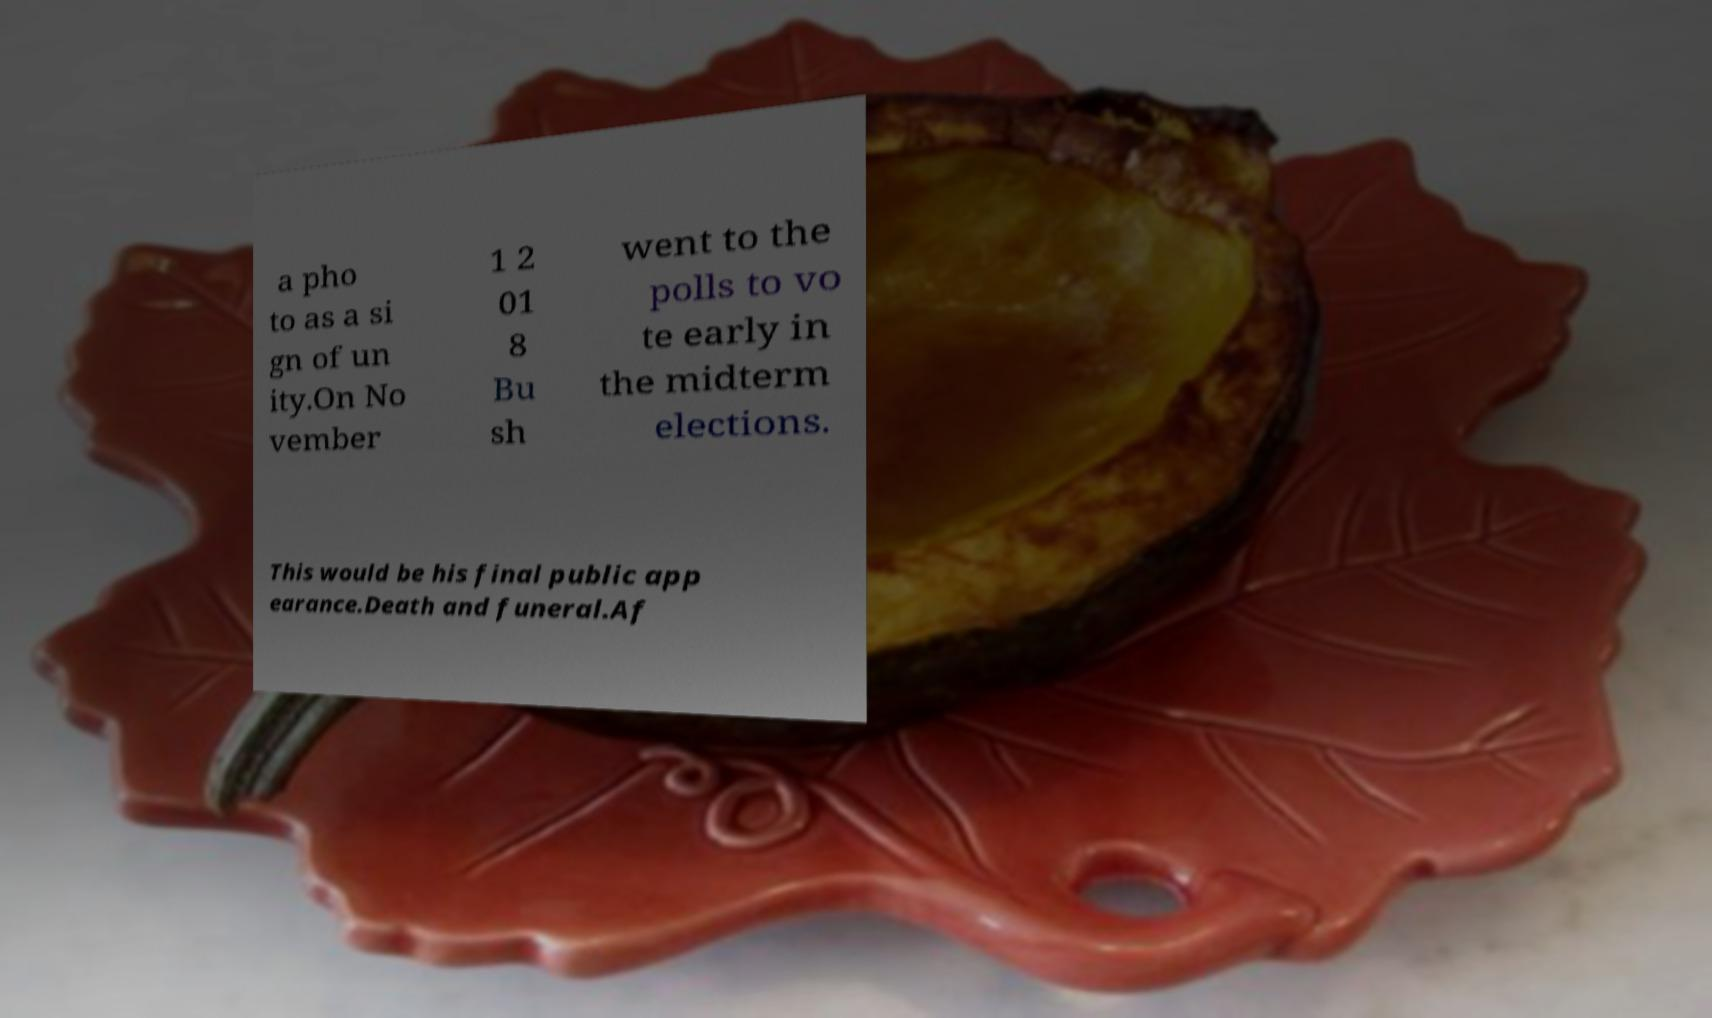I need the written content from this picture converted into text. Can you do that? a pho to as a si gn of un ity.On No vember 1 2 01 8 Bu sh went to the polls to vo te early in the midterm elections. This would be his final public app earance.Death and funeral.Af 